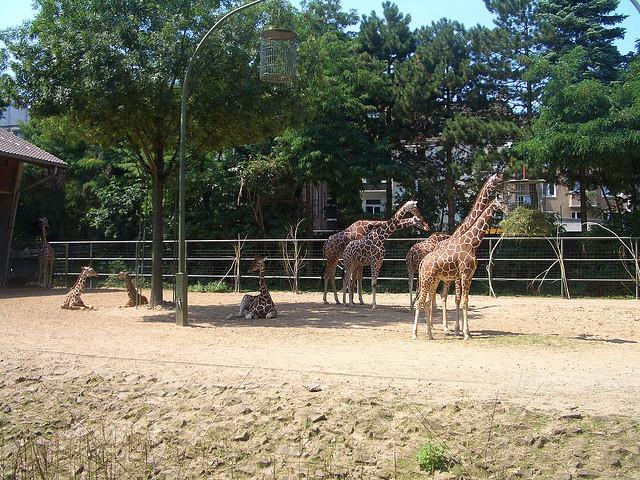What is the giraffe in the middle resting in? Please explain your reasoning. shade. He's under the tree 